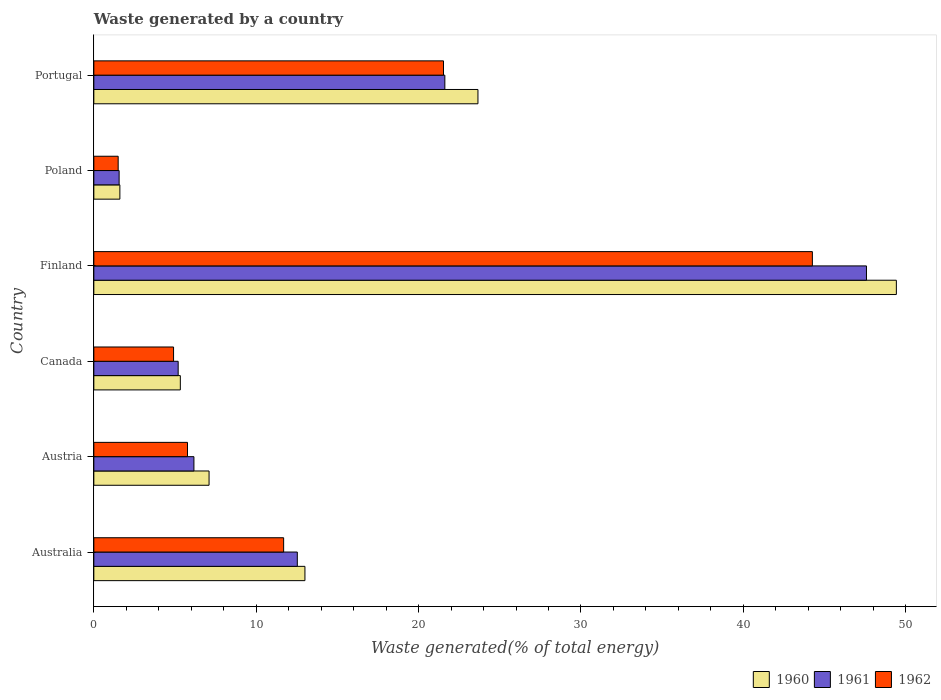How many different coloured bars are there?
Provide a succinct answer. 3. How many groups of bars are there?
Your answer should be compact. 6. Are the number of bars on each tick of the Y-axis equal?
Give a very brief answer. Yes. How many bars are there on the 5th tick from the top?
Ensure brevity in your answer.  3. In how many cases, is the number of bars for a given country not equal to the number of legend labels?
Offer a terse response. 0. What is the total waste generated in 1960 in Portugal?
Keep it short and to the point. 23.66. Across all countries, what is the maximum total waste generated in 1960?
Make the answer very short. 49.42. Across all countries, what is the minimum total waste generated in 1960?
Ensure brevity in your answer.  1.6. In which country was the total waste generated in 1962 maximum?
Provide a short and direct response. Finland. In which country was the total waste generated in 1960 minimum?
Keep it short and to the point. Poland. What is the total total waste generated in 1962 in the graph?
Give a very brief answer. 89.65. What is the difference between the total waste generated in 1962 in Australia and that in Portugal?
Provide a succinct answer. -9.84. What is the difference between the total waste generated in 1961 in Canada and the total waste generated in 1962 in Portugal?
Keep it short and to the point. -16.34. What is the average total waste generated in 1960 per country?
Your response must be concise. 16.68. What is the difference between the total waste generated in 1960 and total waste generated in 1961 in Austria?
Provide a succinct answer. 0.93. What is the ratio of the total waste generated in 1961 in Finland to that in Poland?
Offer a very short reply. 30.53. Is the total waste generated in 1962 in Australia less than that in Finland?
Give a very brief answer. Yes. What is the difference between the highest and the second highest total waste generated in 1960?
Provide a succinct answer. 25.77. What is the difference between the highest and the lowest total waste generated in 1962?
Offer a terse response. 42.75. How many bars are there?
Your answer should be very brief. 18. Are all the bars in the graph horizontal?
Keep it short and to the point. Yes. What is the difference between two consecutive major ticks on the X-axis?
Ensure brevity in your answer.  10. Does the graph contain grids?
Your answer should be compact. No. Where does the legend appear in the graph?
Keep it short and to the point. Bottom right. How are the legend labels stacked?
Your answer should be compact. Horizontal. What is the title of the graph?
Offer a very short reply. Waste generated by a country. What is the label or title of the X-axis?
Offer a terse response. Waste generated(% of total energy). What is the Waste generated(% of total energy) in 1960 in Australia?
Keep it short and to the point. 13. What is the Waste generated(% of total energy) of 1961 in Australia?
Offer a very short reply. 12.53. What is the Waste generated(% of total energy) in 1962 in Australia?
Your answer should be compact. 11.69. What is the Waste generated(% of total energy) of 1960 in Austria?
Your answer should be compact. 7.1. What is the Waste generated(% of total energy) of 1961 in Austria?
Offer a terse response. 6.16. What is the Waste generated(% of total energy) of 1962 in Austria?
Make the answer very short. 5.77. What is the Waste generated(% of total energy) in 1960 in Canada?
Your answer should be compact. 5.33. What is the Waste generated(% of total energy) of 1961 in Canada?
Offer a terse response. 5.19. What is the Waste generated(% of total energy) of 1962 in Canada?
Your answer should be very brief. 4.91. What is the Waste generated(% of total energy) in 1960 in Finland?
Your answer should be compact. 49.42. What is the Waste generated(% of total energy) of 1961 in Finland?
Provide a short and direct response. 47.58. What is the Waste generated(% of total energy) of 1962 in Finland?
Offer a very short reply. 44.25. What is the Waste generated(% of total energy) in 1960 in Poland?
Your answer should be very brief. 1.6. What is the Waste generated(% of total energy) of 1961 in Poland?
Offer a terse response. 1.56. What is the Waste generated(% of total energy) of 1962 in Poland?
Your response must be concise. 1.5. What is the Waste generated(% of total energy) of 1960 in Portugal?
Ensure brevity in your answer.  23.66. What is the Waste generated(% of total energy) in 1961 in Portugal?
Your answer should be very brief. 21.62. What is the Waste generated(% of total energy) in 1962 in Portugal?
Keep it short and to the point. 21.53. Across all countries, what is the maximum Waste generated(% of total energy) in 1960?
Make the answer very short. 49.42. Across all countries, what is the maximum Waste generated(% of total energy) in 1961?
Make the answer very short. 47.58. Across all countries, what is the maximum Waste generated(% of total energy) in 1962?
Your response must be concise. 44.25. Across all countries, what is the minimum Waste generated(% of total energy) of 1960?
Your response must be concise. 1.6. Across all countries, what is the minimum Waste generated(% of total energy) of 1961?
Provide a succinct answer. 1.56. Across all countries, what is the minimum Waste generated(% of total energy) of 1962?
Ensure brevity in your answer.  1.5. What is the total Waste generated(% of total energy) in 1960 in the graph?
Make the answer very short. 100.11. What is the total Waste generated(% of total energy) of 1961 in the graph?
Keep it short and to the point. 94.65. What is the total Waste generated(% of total energy) of 1962 in the graph?
Ensure brevity in your answer.  89.65. What is the difference between the Waste generated(% of total energy) of 1960 in Australia and that in Austria?
Offer a terse response. 5.9. What is the difference between the Waste generated(% of total energy) of 1961 in Australia and that in Austria?
Provide a succinct answer. 6.37. What is the difference between the Waste generated(% of total energy) of 1962 in Australia and that in Austria?
Give a very brief answer. 5.92. What is the difference between the Waste generated(% of total energy) of 1960 in Australia and that in Canada?
Provide a succinct answer. 7.67. What is the difference between the Waste generated(% of total energy) in 1961 in Australia and that in Canada?
Give a very brief answer. 7.34. What is the difference between the Waste generated(% of total energy) of 1962 in Australia and that in Canada?
Your answer should be very brief. 6.78. What is the difference between the Waste generated(% of total energy) of 1960 in Australia and that in Finland?
Ensure brevity in your answer.  -36.42. What is the difference between the Waste generated(% of total energy) of 1961 in Australia and that in Finland?
Make the answer very short. -35.05. What is the difference between the Waste generated(% of total energy) of 1962 in Australia and that in Finland?
Offer a terse response. -32.56. What is the difference between the Waste generated(% of total energy) in 1960 in Australia and that in Poland?
Provide a succinct answer. 11.4. What is the difference between the Waste generated(% of total energy) of 1961 in Australia and that in Poland?
Provide a short and direct response. 10.97. What is the difference between the Waste generated(% of total energy) of 1962 in Australia and that in Poland?
Offer a terse response. 10.19. What is the difference between the Waste generated(% of total energy) in 1960 in Australia and that in Portugal?
Offer a very short reply. -10.65. What is the difference between the Waste generated(% of total energy) of 1961 in Australia and that in Portugal?
Provide a succinct answer. -9.09. What is the difference between the Waste generated(% of total energy) of 1962 in Australia and that in Portugal?
Give a very brief answer. -9.84. What is the difference between the Waste generated(% of total energy) in 1960 in Austria and that in Canada?
Your answer should be compact. 1.77. What is the difference between the Waste generated(% of total energy) of 1961 in Austria and that in Canada?
Give a very brief answer. 0.97. What is the difference between the Waste generated(% of total energy) in 1962 in Austria and that in Canada?
Your answer should be compact. 0.86. What is the difference between the Waste generated(% of total energy) of 1960 in Austria and that in Finland?
Offer a very short reply. -42.33. What is the difference between the Waste generated(% of total energy) in 1961 in Austria and that in Finland?
Make the answer very short. -41.42. What is the difference between the Waste generated(% of total energy) in 1962 in Austria and that in Finland?
Your answer should be compact. -38.48. What is the difference between the Waste generated(% of total energy) in 1960 in Austria and that in Poland?
Give a very brief answer. 5.49. What is the difference between the Waste generated(% of total energy) of 1961 in Austria and that in Poland?
Keep it short and to the point. 4.61. What is the difference between the Waste generated(% of total energy) in 1962 in Austria and that in Poland?
Keep it short and to the point. 4.27. What is the difference between the Waste generated(% of total energy) in 1960 in Austria and that in Portugal?
Offer a very short reply. -16.56. What is the difference between the Waste generated(% of total energy) of 1961 in Austria and that in Portugal?
Your response must be concise. -15.45. What is the difference between the Waste generated(% of total energy) of 1962 in Austria and that in Portugal?
Ensure brevity in your answer.  -15.76. What is the difference between the Waste generated(% of total energy) in 1960 in Canada and that in Finland?
Your response must be concise. -44.1. What is the difference between the Waste generated(% of total energy) of 1961 in Canada and that in Finland?
Offer a very short reply. -42.39. What is the difference between the Waste generated(% of total energy) in 1962 in Canada and that in Finland?
Your answer should be very brief. -39.34. What is the difference between the Waste generated(% of total energy) in 1960 in Canada and that in Poland?
Provide a short and direct response. 3.72. What is the difference between the Waste generated(% of total energy) of 1961 in Canada and that in Poland?
Provide a succinct answer. 3.64. What is the difference between the Waste generated(% of total energy) of 1962 in Canada and that in Poland?
Make the answer very short. 3.41. What is the difference between the Waste generated(% of total energy) of 1960 in Canada and that in Portugal?
Offer a very short reply. -18.33. What is the difference between the Waste generated(% of total energy) of 1961 in Canada and that in Portugal?
Ensure brevity in your answer.  -16.42. What is the difference between the Waste generated(% of total energy) of 1962 in Canada and that in Portugal?
Give a very brief answer. -16.62. What is the difference between the Waste generated(% of total energy) in 1960 in Finland and that in Poland?
Your answer should be compact. 47.82. What is the difference between the Waste generated(% of total energy) of 1961 in Finland and that in Poland?
Make the answer very short. 46.02. What is the difference between the Waste generated(% of total energy) in 1962 in Finland and that in Poland?
Offer a very short reply. 42.75. What is the difference between the Waste generated(% of total energy) in 1960 in Finland and that in Portugal?
Your response must be concise. 25.77. What is the difference between the Waste generated(% of total energy) of 1961 in Finland and that in Portugal?
Your response must be concise. 25.96. What is the difference between the Waste generated(% of total energy) in 1962 in Finland and that in Portugal?
Make the answer very short. 22.72. What is the difference between the Waste generated(% of total energy) of 1960 in Poland and that in Portugal?
Make the answer very short. -22.05. What is the difference between the Waste generated(% of total energy) of 1961 in Poland and that in Portugal?
Offer a very short reply. -20.06. What is the difference between the Waste generated(% of total energy) in 1962 in Poland and that in Portugal?
Provide a short and direct response. -20.03. What is the difference between the Waste generated(% of total energy) in 1960 in Australia and the Waste generated(% of total energy) in 1961 in Austria?
Give a very brief answer. 6.84. What is the difference between the Waste generated(% of total energy) in 1960 in Australia and the Waste generated(% of total energy) in 1962 in Austria?
Offer a terse response. 7.23. What is the difference between the Waste generated(% of total energy) in 1961 in Australia and the Waste generated(% of total energy) in 1962 in Austria?
Offer a terse response. 6.76. What is the difference between the Waste generated(% of total energy) in 1960 in Australia and the Waste generated(% of total energy) in 1961 in Canada?
Provide a succinct answer. 7.81. What is the difference between the Waste generated(% of total energy) in 1960 in Australia and the Waste generated(% of total energy) in 1962 in Canada?
Your answer should be very brief. 8.09. What is the difference between the Waste generated(% of total energy) of 1961 in Australia and the Waste generated(% of total energy) of 1962 in Canada?
Your answer should be compact. 7.62. What is the difference between the Waste generated(% of total energy) of 1960 in Australia and the Waste generated(% of total energy) of 1961 in Finland?
Your answer should be compact. -34.58. What is the difference between the Waste generated(% of total energy) of 1960 in Australia and the Waste generated(% of total energy) of 1962 in Finland?
Give a very brief answer. -31.25. What is the difference between the Waste generated(% of total energy) of 1961 in Australia and the Waste generated(% of total energy) of 1962 in Finland?
Your response must be concise. -31.72. What is the difference between the Waste generated(% of total energy) in 1960 in Australia and the Waste generated(% of total energy) in 1961 in Poland?
Your answer should be very brief. 11.44. What is the difference between the Waste generated(% of total energy) of 1960 in Australia and the Waste generated(% of total energy) of 1962 in Poland?
Give a very brief answer. 11.5. What is the difference between the Waste generated(% of total energy) of 1961 in Australia and the Waste generated(% of total energy) of 1962 in Poland?
Make the answer very short. 11.03. What is the difference between the Waste generated(% of total energy) of 1960 in Australia and the Waste generated(% of total energy) of 1961 in Portugal?
Keep it short and to the point. -8.62. What is the difference between the Waste generated(% of total energy) of 1960 in Australia and the Waste generated(% of total energy) of 1962 in Portugal?
Give a very brief answer. -8.53. What is the difference between the Waste generated(% of total energy) of 1961 in Australia and the Waste generated(% of total energy) of 1962 in Portugal?
Provide a succinct answer. -9. What is the difference between the Waste generated(% of total energy) in 1960 in Austria and the Waste generated(% of total energy) in 1961 in Canada?
Give a very brief answer. 1.9. What is the difference between the Waste generated(% of total energy) in 1960 in Austria and the Waste generated(% of total energy) in 1962 in Canada?
Offer a very short reply. 2.19. What is the difference between the Waste generated(% of total energy) in 1961 in Austria and the Waste generated(% of total energy) in 1962 in Canada?
Provide a short and direct response. 1.25. What is the difference between the Waste generated(% of total energy) of 1960 in Austria and the Waste generated(% of total energy) of 1961 in Finland?
Your response must be concise. -40.48. What is the difference between the Waste generated(% of total energy) in 1960 in Austria and the Waste generated(% of total energy) in 1962 in Finland?
Your answer should be compact. -37.15. What is the difference between the Waste generated(% of total energy) in 1961 in Austria and the Waste generated(% of total energy) in 1962 in Finland?
Ensure brevity in your answer.  -38.09. What is the difference between the Waste generated(% of total energy) of 1960 in Austria and the Waste generated(% of total energy) of 1961 in Poland?
Your answer should be very brief. 5.54. What is the difference between the Waste generated(% of total energy) of 1960 in Austria and the Waste generated(% of total energy) of 1962 in Poland?
Your response must be concise. 5.6. What is the difference between the Waste generated(% of total energy) of 1961 in Austria and the Waste generated(% of total energy) of 1962 in Poland?
Ensure brevity in your answer.  4.67. What is the difference between the Waste generated(% of total energy) in 1960 in Austria and the Waste generated(% of total energy) in 1961 in Portugal?
Provide a succinct answer. -14.52. What is the difference between the Waste generated(% of total energy) in 1960 in Austria and the Waste generated(% of total energy) in 1962 in Portugal?
Make the answer very short. -14.44. What is the difference between the Waste generated(% of total energy) in 1961 in Austria and the Waste generated(% of total energy) in 1962 in Portugal?
Make the answer very short. -15.37. What is the difference between the Waste generated(% of total energy) in 1960 in Canada and the Waste generated(% of total energy) in 1961 in Finland?
Your answer should be very brief. -42.25. What is the difference between the Waste generated(% of total energy) in 1960 in Canada and the Waste generated(% of total energy) in 1962 in Finland?
Make the answer very short. -38.92. What is the difference between the Waste generated(% of total energy) of 1961 in Canada and the Waste generated(% of total energy) of 1962 in Finland?
Provide a short and direct response. -39.06. What is the difference between the Waste generated(% of total energy) in 1960 in Canada and the Waste generated(% of total energy) in 1961 in Poland?
Keep it short and to the point. 3.77. What is the difference between the Waste generated(% of total energy) of 1960 in Canada and the Waste generated(% of total energy) of 1962 in Poland?
Make the answer very short. 3.83. What is the difference between the Waste generated(% of total energy) in 1961 in Canada and the Waste generated(% of total energy) in 1962 in Poland?
Ensure brevity in your answer.  3.7. What is the difference between the Waste generated(% of total energy) in 1960 in Canada and the Waste generated(% of total energy) in 1961 in Portugal?
Ensure brevity in your answer.  -16.29. What is the difference between the Waste generated(% of total energy) in 1960 in Canada and the Waste generated(% of total energy) in 1962 in Portugal?
Offer a very short reply. -16.21. What is the difference between the Waste generated(% of total energy) in 1961 in Canada and the Waste generated(% of total energy) in 1962 in Portugal?
Keep it short and to the point. -16.34. What is the difference between the Waste generated(% of total energy) in 1960 in Finland and the Waste generated(% of total energy) in 1961 in Poland?
Offer a very short reply. 47.86. What is the difference between the Waste generated(% of total energy) of 1960 in Finland and the Waste generated(% of total energy) of 1962 in Poland?
Provide a succinct answer. 47.92. What is the difference between the Waste generated(% of total energy) of 1961 in Finland and the Waste generated(% of total energy) of 1962 in Poland?
Provide a succinct answer. 46.08. What is the difference between the Waste generated(% of total energy) of 1960 in Finland and the Waste generated(% of total energy) of 1961 in Portugal?
Your answer should be very brief. 27.81. What is the difference between the Waste generated(% of total energy) in 1960 in Finland and the Waste generated(% of total energy) in 1962 in Portugal?
Provide a succinct answer. 27.89. What is the difference between the Waste generated(% of total energy) of 1961 in Finland and the Waste generated(% of total energy) of 1962 in Portugal?
Keep it short and to the point. 26.05. What is the difference between the Waste generated(% of total energy) of 1960 in Poland and the Waste generated(% of total energy) of 1961 in Portugal?
Keep it short and to the point. -20.01. What is the difference between the Waste generated(% of total energy) of 1960 in Poland and the Waste generated(% of total energy) of 1962 in Portugal?
Provide a short and direct response. -19.93. What is the difference between the Waste generated(% of total energy) of 1961 in Poland and the Waste generated(% of total energy) of 1962 in Portugal?
Your response must be concise. -19.98. What is the average Waste generated(% of total energy) in 1960 per country?
Your response must be concise. 16.68. What is the average Waste generated(% of total energy) of 1961 per country?
Your answer should be compact. 15.77. What is the average Waste generated(% of total energy) in 1962 per country?
Offer a terse response. 14.94. What is the difference between the Waste generated(% of total energy) in 1960 and Waste generated(% of total energy) in 1961 in Australia?
Provide a short and direct response. 0.47. What is the difference between the Waste generated(% of total energy) in 1960 and Waste generated(% of total energy) in 1962 in Australia?
Your answer should be compact. 1.31. What is the difference between the Waste generated(% of total energy) in 1961 and Waste generated(% of total energy) in 1962 in Australia?
Offer a terse response. 0.84. What is the difference between the Waste generated(% of total energy) of 1960 and Waste generated(% of total energy) of 1961 in Austria?
Offer a terse response. 0.93. What is the difference between the Waste generated(% of total energy) of 1960 and Waste generated(% of total energy) of 1962 in Austria?
Ensure brevity in your answer.  1.33. What is the difference between the Waste generated(% of total energy) in 1961 and Waste generated(% of total energy) in 1962 in Austria?
Provide a short and direct response. 0.4. What is the difference between the Waste generated(% of total energy) in 1960 and Waste generated(% of total energy) in 1961 in Canada?
Offer a terse response. 0.13. What is the difference between the Waste generated(% of total energy) of 1960 and Waste generated(% of total energy) of 1962 in Canada?
Give a very brief answer. 0.42. What is the difference between the Waste generated(% of total energy) in 1961 and Waste generated(% of total energy) in 1962 in Canada?
Offer a very short reply. 0.28. What is the difference between the Waste generated(% of total energy) of 1960 and Waste generated(% of total energy) of 1961 in Finland?
Keep it short and to the point. 1.84. What is the difference between the Waste generated(% of total energy) in 1960 and Waste generated(% of total energy) in 1962 in Finland?
Keep it short and to the point. 5.17. What is the difference between the Waste generated(% of total energy) of 1961 and Waste generated(% of total energy) of 1962 in Finland?
Provide a short and direct response. 3.33. What is the difference between the Waste generated(% of total energy) in 1960 and Waste generated(% of total energy) in 1961 in Poland?
Make the answer very short. 0.05. What is the difference between the Waste generated(% of total energy) in 1960 and Waste generated(% of total energy) in 1962 in Poland?
Provide a short and direct response. 0.11. What is the difference between the Waste generated(% of total energy) in 1961 and Waste generated(% of total energy) in 1962 in Poland?
Ensure brevity in your answer.  0.06. What is the difference between the Waste generated(% of total energy) of 1960 and Waste generated(% of total energy) of 1961 in Portugal?
Give a very brief answer. 2.04. What is the difference between the Waste generated(% of total energy) of 1960 and Waste generated(% of total energy) of 1962 in Portugal?
Make the answer very short. 2.12. What is the difference between the Waste generated(% of total energy) in 1961 and Waste generated(% of total energy) in 1962 in Portugal?
Offer a very short reply. 0.08. What is the ratio of the Waste generated(% of total energy) in 1960 in Australia to that in Austria?
Provide a succinct answer. 1.83. What is the ratio of the Waste generated(% of total energy) of 1961 in Australia to that in Austria?
Your answer should be very brief. 2.03. What is the ratio of the Waste generated(% of total energy) in 1962 in Australia to that in Austria?
Ensure brevity in your answer.  2.03. What is the ratio of the Waste generated(% of total energy) of 1960 in Australia to that in Canada?
Keep it short and to the point. 2.44. What is the ratio of the Waste generated(% of total energy) in 1961 in Australia to that in Canada?
Your answer should be very brief. 2.41. What is the ratio of the Waste generated(% of total energy) of 1962 in Australia to that in Canada?
Give a very brief answer. 2.38. What is the ratio of the Waste generated(% of total energy) of 1960 in Australia to that in Finland?
Your response must be concise. 0.26. What is the ratio of the Waste generated(% of total energy) in 1961 in Australia to that in Finland?
Provide a short and direct response. 0.26. What is the ratio of the Waste generated(% of total energy) in 1962 in Australia to that in Finland?
Your answer should be very brief. 0.26. What is the ratio of the Waste generated(% of total energy) of 1960 in Australia to that in Poland?
Give a very brief answer. 8.1. What is the ratio of the Waste generated(% of total energy) of 1961 in Australia to that in Poland?
Your answer should be compact. 8.04. What is the ratio of the Waste generated(% of total energy) of 1962 in Australia to that in Poland?
Your answer should be compact. 7.8. What is the ratio of the Waste generated(% of total energy) of 1960 in Australia to that in Portugal?
Offer a terse response. 0.55. What is the ratio of the Waste generated(% of total energy) of 1961 in Australia to that in Portugal?
Ensure brevity in your answer.  0.58. What is the ratio of the Waste generated(% of total energy) in 1962 in Australia to that in Portugal?
Your answer should be very brief. 0.54. What is the ratio of the Waste generated(% of total energy) of 1960 in Austria to that in Canada?
Offer a very short reply. 1.33. What is the ratio of the Waste generated(% of total energy) of 1961 in Austria to that in Canada?
Your answer should be very brief. 1.19. What is the ratio of the Waste generated(% of total energy) in 1962 in Austria to that in Canada?
Make the answer very short. 1.17. What is the ratio of the Waste generated(% of total energy) of 1960 in Austria to that in Finland?
Offer a terse response. 0.14. What is the ratio of the Waste generated(% of total energy) of 1961 in Austria to that in Finland?
Your answer should be compact. 0.13. What is the ratio of the Waste generated(% of total energy) of 1962 in Austria to that in Finland?
Offer a very short reply. 0.13. What is the ratio of the Waste generated(% of total energy) of 1960 in Austria to that in Poland?
Offer a terse response. 4.42. What is the ratio of the Waste generated(% of total energy) of 1961 in Austria to that in Poland?
Your answer should be compact. 3.96. What is the ratio of the Waste generated(% of total energy) in 1962 in Austria to that in Poland?
Offer a very short reply. 3.85. What is the ratio of the Waste generated(% of total energy) in 1960 in Austria to that in Portugal?
Offer a very short reply. 0.3. What is the ratio of the Waste generated(% of total energy) of 1961 in Austria to that in Portugal?
Provide a succinct answer. 0.29. What is the ratio of the Waste generated(% of total energy) in 1962 in Austria to that in Portugal?
Ensure brevity in your answer.  0.27. What is the ratio of the Waste generated(% of total energy) of 1960 in Canada to that in Finland?
Provide a succinct answer. 0.11. What is the ratio of the Waste generated(% of total energy) in 1961 in Canada to that in Finland?
Provide a short and direct response. 0.11. What is the ratio of the Waste generated(% of total energy) in 1962 in Canada to that in Finland?
Make the answer very short. 0.11. What is the ratio of the Waste generated(% of total energy) in 1960 in Canada to that in Poland?
Provide a short and direct response. 3.32. What is the ratio of the Waste generated(% of total energy) in 1961 in Canada to that in Poland?
Provide a succinct answer. 3.33. What is the ratio of the Waste generated(% of total energy) of 1962 in Canada to that in Poland?
Offer a terse response. 3.28. What is the ratio of the Waste generated(% of total energy) of 1960 in Canada to that in Portugal?
Provide a short and direct response. 0.23. What is the ratio of the Waste generated(% of total energy) in 1961 in Canada to that in Portugal?
Offer a very short reply. 0.24. What is the ratio of the Waste generated(% of total energy) in 1962 in Canada to that in Portugal?
Ensure brevity in your answer.  0.23. What is the ratio of the Waste generated(% of total energy) in 1960 in Finland to that in Poland?
Provide a succinct answer. 30.8. What is the ratio of the Waste generated(% of total energy) of 1961 in Finland to that in Poland?
Provide a succinct answer. 30.53. What is the ratio of the Waste generated(% of total energy) of 1962 in Finland to that in Poland?
Ensure brevity in your answer.  29.52. What is the ratio of the Waste generated(% of total energy) in 1960 in Finland to that in Portugal?
Your answer should be compact. 2.09. What is the ratio of the Waste generated(% of total energy) in 1961 in Finland to that in Portugal?
Keep it short and to the point. 2.2. What is the ratio of the Waste generated(% of total energy) in 1962 in Finland to that in Portugal?
Offer a terse response. 2.05. What is the ratio of the Waste generated(% of total energy) in 1960 in Poland to that in Portugal?
Keep it short and to the point. 0.07. What is the ratio of the Waste generated(% of total energy) in 1961 in Poland to that in Portugal?
Offer a very short reply. 0.07. What is the ratio of the Waste generated(% of total energy) in 1962 in Poland to that in Portugal?
Ensure brevity in your answer.  0.07. What is the difference between the highest and the second highest Waste generated(% of total energy) of 1960?
Offer a very short reply. 25.77. What is the difference between the highest and the second highest Waste generated(% of total energy) of 1961?
Give a very brief answer. 25.96. What is the difference between the highest and the second highest Waste generated(% of total energy) in 1962?
Keep it short and to the point. 22.72. What is the difference between the highest and the lowest Waste generated(% of total energy) in 1960?
Make the answer very short. 47.82. What is the difference between the highest and the lowest Waste generated(% of total energy) of 1961?
Offer a very short reply. 46.02. What is the difference between the highest and the lowest Waste generated(% of total energy) in 1962?
Give a very brief answer. 42.75. 